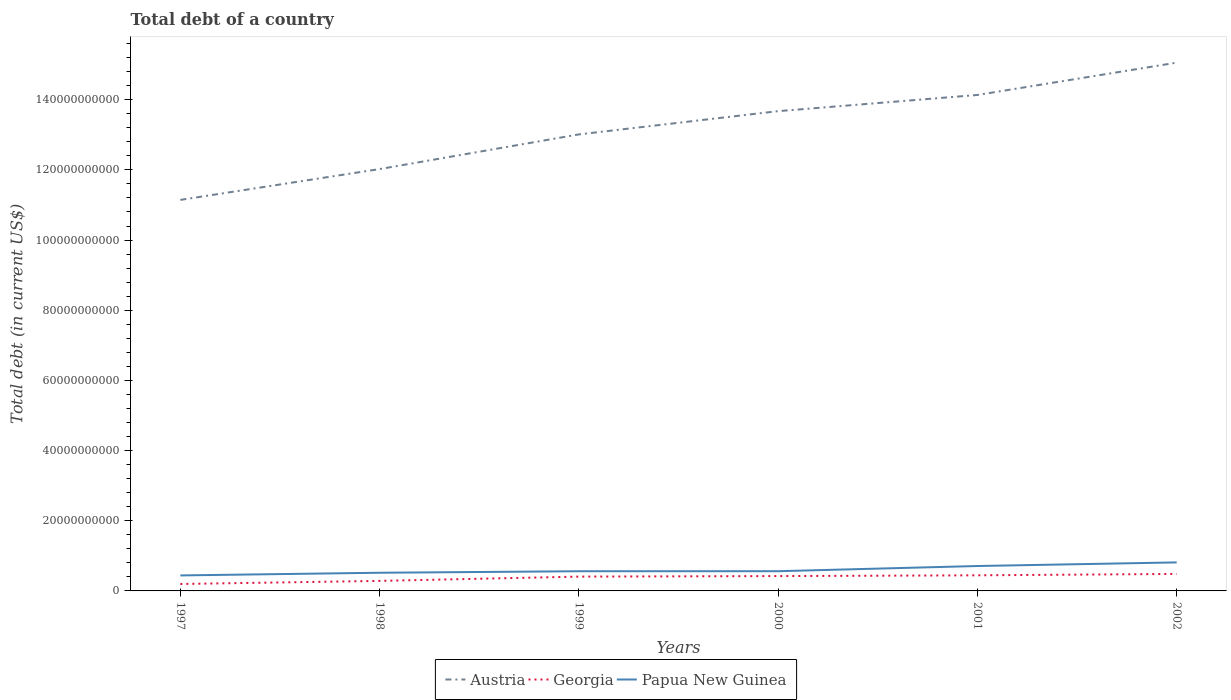Is the number of lines equal to the number of legend labels?
Keep it short and to the point. Yes. Across all years, what is the maximum debt in Papua New Guinea?
Offer a terse response. 4.42e+09. In which year was the debt in Papua New Guinea maximum?
Offer a very short reply. 1997. What is the total debt in Papua New Guinea in the graph?
Keep it short and to the point. -2.68e+09. What is the difference between the highest and the second highest debt in Papua New Guinea?
Your response must be concise. 3.71e+09. Does the graph contain any zero values?
Provide a short and direct response. No. Does the graph contain grids?
Make the answer very short. No. How many legend labels are there?
Your answer should be compact. 3. What is the title of the graph?
Give a very brief answer. Total debt of a country. Does "Libya" appear as one of the legend labels in the graph?
Offer a terse response. No. What is the label or title of the Y-axis?
Your answer should be very brief. Total debt (in current US$). What is the Total debt (in current US$) of Austria in 1997?
Offer a terse response. 1.11e+11. What is the Total debt (in current US$) of Georgia in 1997?
Your answer should be compact. 1.98e+09. What is the Total debt (in current US$) of Papua New Guinea in 1997?
Your answer should be compact. 4.42e+09. What is the Total debt (in current US$) of Austria in 1998?
Ensure brevity in your answer.  1.20e+11. What is the Total debt (in current US$) in Georgia in 1998?
Make the answer very short. 2.86e+09. What is the Total debt (in current US$) of Papua New Guinea in 1998?
Provide a succinct answer. 5.18e+09. What is the Total debt (in current US$) of Austria in 1999?
Offer a very short reply. 1.30e+11. What is the Total debt (in current US$) of Georgia in 1999?
Keep it short and to the point. 4.08e+09. What is the Total debt (in current US$) of Papua New Guinea in 1999?
Provide a short and direct response. 5.61e+09. What is the Total debt (in current US$) of Austria in 2000?
Keep it short and to the point. 1.37e+11. What is the Total debt (in current US$) in Georgia in 2000?
Offer a terse response. 4.23e+09. What is the Total debt (in current US$) of Papua New Guinea in 2000?
Make the answer very short. 5.62e+09. What is the Total debt (in current US$) in Austria in 2001?
Offer a very short reply. 1.41e+11. What is the Total debt (in current US$) in Georgia in 2001?
Keep it short and to the point. 4.45e+09. What is the Total debt (in current US$) in Papua New Guinea in 2001?
Provide a short and direct response. 7.10e+09. What is the Total debt (in current US$) in Austria in 2002?
Offer a very short reply. 1.51e+11. What is the Total debt (in current US$) in Georgia in 2002?
Your response must be concise. 4.84e+09. What is the Total debt (in current US$) in Papua New Guinea in 2002?
Your response must be concise. 8.13e+09. Across all years, what is the maximum Total debt (in current US$) in Austria?
Your answer should be very brief. 1.51e+11. Across all years, what is the maximum Total debt (in current US$) in Georgia?
Provide a short and direct response. 4.84e+09. Across all years, what is the maximum Total debt (in current US$) of Papua New Guinea?
Offer a very short reply. 8.13e+09. Across all years, what is the minimum Total debt (in current US$) of Austria?
Your response must be concise. 1.11e+11. Across all years, what is the minimum Total debt (in current US$) in Georgia?
Your answer should be very brief. 1.98e+09. Across all years, what is the minimum Total debt (in current US$) of Papua New Guinea?
Make the answer very short. 4.42e+09. What is the total Total debt (in current US$) of Austria in the graph?
Give a very brief answer. 7.90e+11. What is the total Total debt (in current US$) of Georgia in the graph?
Offer a terse response. 2.24e+1. What is the total Total debt (in current US$) of Papua New Guinea in the graph?
Provide a succinct answer. 3.61e+1. What is the difference between the Total debt (in current US$) in Austria in 1997 and that in 1998?
Your answer should be very brief. -8.79e+09. What is the difference between the Total debt (in current US$) of Georgia in 1997 and that in 1998?
Keep it short and to the point. -8.81e+08. What is the difference between the Total debt (in current US$) of Papua New Guinea in 1997 and that in 1998?
Give a very brief answer. -7.60e+08. What is the difference between the Total debt (in current US$) of Austria in 1997 and that in 1999?
Ensure brevity in your answer.  -1.87e+1. What is the difference between the Total debt (in current US$) of Georgia in 1997 and that in 1999?
Provide a succinct answer. -2.10e+09. What is the difference between the Total debt (in current US$) in Papua New Guinea in 1997 and that in 1999?
Give a very brief answer. -1.19e+09. What is the difference between the Total debt (in current US$) of Austria in 1997 and that in 2000?
Provide a succinct answer. -2.53e+1. What is the difference between the Total debt (in current US$) in Georgia in 1997 and that in 2000?
Your answer should be very brief. -2.25e+09. What is the difference between the Total debt (in current US$) of Papua New Guinea in 1997 and that in 2000?
Provide a short and direct response. -1.20e+09. What is the difference between the Total debt (in current US$) in Austria in 1997 and that in 2001?
Offer a very short reply. -2.99e+1. What is the difference between the Total debt (in current US$) in Georgia in 1997 and that in 2001?
Your response must be concise. -2.47e+09. What is the difference between the Total debt (in current US$) in Papua New Guinea in 1997 and that in 2001?
Your answer should be very brief. -2.68e+09. What is the difference between the Total debt (in current US$) of Austria in 1997 and that in 2002?
Your response must be concise. -3.91e+1. What is the difference between the Total debt (in current US$) in Georgia in 1997 and that in 2002?
Your answer should be very brief. -2.87e+09. What is the difference between the Total debt (in current US$) of Papua New Guinea in 1997 and that in 2002?
Your response must be concise. -3.71e+09. What is the difference between the Total debt (in current US$) in Austria in 1998 and that in 1999?
Your answer should be compact. -9.88e+09. What is the difference between the Total debt (in current US$) in Georgia in 1998 and that in 1999?
Ensure brevity in your answer.  -1.22e+09. What is the difference between the Total debt (in current US$) in Papua New Guinea in 1998 and that in 1999?
Provide a short and direct response. -4.32e+08. What is the difference between the Total debt (in current US$) in Austria in 1998 and that in 2000?
Ensure brevity in your answer.  -1.65e+1. What is the difference between the Total debt (in current US$) of Georgia in 1998 and that in 2000?
Ensure brevity in your answer.  -1.37e+09. What is the difference between the Total debt (in current US$) of Papua New Guinea in 1998 and that in 2000?
Provide a short and direct response. -4.44e+08. What is the difference between the Total debt (in current US$) in Austria in 1998 and that in 2001?
Offer a terse response. -2.11e+1. What is the difference between the Total debt (in current US$) in Georgia in 1998 and that in 2001?
Provide a succinct answer. -1.59e+09. What is the difference between the Total debt (in current US$) of Papua New Guinea in 1998 and that in 2001?
Provide a short and direct response. -1.92e+09. What is the difference between the Total debt (in current US$) in Austria in 1998 and that in 2002?
Provide a short and direct response. -3.03e+1. What is the difference between the Total debt (in current US$) in Georgia in 1998 and that in 2002?
Your answer should be very brief. -1.99e+09. What is the difference between the Total debt (in current US$) of Papua New Guinea in 1998 and that in 2002?
Your answer should be compact. -2.95e+09. What is the difference between the Total debt (in current US$) in Austria in 1999 and that in 2000?
Keep it short and to the point. -6.63e+09. What is the difference between the Total debt (in current US$) in Georgia in 1999 and that in 2000?
Your response must be concise. -1.48e+08. What is the difference between the Total debt (in current US$) in Papua New Guinea in 1999 and that in 2000?
Your response must be concise. -1.24e+07. What is the difference between the Total debt (in current US$) in Austria in 1999 and that in 2001?
Offer a very short reply. -1.12e+1. What is the difference between the Total debt (in current US$) in Georgia in 1999 and that in 2001?
Provide a succinct answer. -3.72e+08. What is the difference between the Total debt (in current US$) of Papua New Guinea in 1999 and that in 2001?
Give a very brief answer. -1.49e+09. What is the difference between the Total debt (in current US$) in Austria in 1999 and that in 2002?
Offer a very short reply. -2.05e+1. What is the difference between the Total debt (in current US$) in Georgia in 1999 and that in 2002?
Provide a short and direct response. -7.65e+08. What is the difference between the Total debt (in current US$) of Papua New Guinea in 1999 and that in 2002?
Your response must be concise. -2.52e+09. What is the difference between the Total debt (in current US$) in Austria in 2000 and that in 2001?
Offer a terse response. -4.61e+09. What is the difference between the Total debt (in current US$) in Georgia in 2000 and that in 2001?
Make the answer very short. -2.23e+08. What is the difference between the Total debt (in current US$) in Papua New Guinea in 2000 and that in 2001?
Give a very brief answer. -1.48e+09. What is the difference between the Total debt (in current US$) in Austria in 2000 and that in 2002?
Your answer should be very brief. -1.38e+1. What is the difference between the Total debt (in current US$) of Georgia in 2000 and that in 2002?
Your response must be concise. -6.17e+08. What is the difference between the Total debt (in current US$) of Papua New Guinea in 2000 and that in 2002?
Provide a short and direct response. -2.51e+09. What is the difference between the Total debt (in current US$) of Austria in 2001 and that in 2002?
Provide a succinct answer. -9.21e+09. What is the difference between the Total debt (in current US$) of Georgia in 2001 and that in 2002?
Your answer should be compact. -3.94e+08. What is the difference between the Total debt (in current US$) of Papua New Guinea in 2001 and that in 2002?
Make the answer very short. -1.03e+09. What is the difference between the Total debt (in current US$) in Austria in 1997 and the Total debt (in current US$) in Georgia in 1998?
Offer a very short reply. 1.09e+11. What is the difference between the Total debt (in current US$) in Austria in 1997 and the Total debt (in current US$) in Papua New Guinea in 1998?
Make the answer very short. 1.06e+11. What is the difference between the Total debt (in current US$) in Georgia in 1997 and the Total debt (in current US$) in Papua New Guinea in 1998?
Ensure brevity in your answer.  -3.20e+09. What is the difference between the Total debt (in current US$) of Austria in 1997 and the Total debt (in current US$) of Georgia in 1999?
Ensure brevity in your answer.  1.07e+11. What is the difference between the Total debt (in current US$) in Austria in 1997 and the Total debt (in current US$) in Papua New Guinea in 1999?
Ensure brevity in your answer.  1.06e+11. What is the difference between the Total debt (in current US$) in Georgia in 1997 and the Total debt (in current US$) in Papua New Guinea in 1999?
Provide a short and direct response. -3.63e+09. What is the difference between the Total debt (in current US$) of Austria in 1997 and the Total debt (in current US$) of Georgia in 2000?
Keep it short and to the point. 1.07e+11. What is the difference between the Total debt (in current US$) in Austria in 1997 and the Total debt (in current US$) in Papua New Guinea in 2000?
Your response must be concise. 1.06e+11. What is the difference between the Total debt (in current US$) in Georgia in 1997 and the Total debt (in current US$) in Papua New Guinea in 2000?
Offer a very short reply. -3.64e+09. What is the difference between the Total debt (in current US$) of Austria in 1997 and the Total debt (in current US$) of Georgia in 2001?
Offer a very short reply. 1.07e+11. What is the difference between the Total debt (in current US$) in Austria in 1997 and the Total debt (in current US$) in Papua New Guinea in 2001?
Give a very brief answer. 1.04e+11. What is the difference between the Total debt (in current US$) of Georgia in 1997 and the Total debt (in current US$) of Papua New Guinea in 2001?
Offer a very short reply. -5.12e+09. What is the difference between the Total debt (in current US$) in Austria in 1997 and the Total debt (in current US$) in Georgia in 2002?
Provide a succinct answer. 1.07e+11. What is the difference between the Total debt (in current US$) in Austria in 1997 and the Total debt (in current US$) in Papua New Guinea in 2002?
Give a very brief answer. 1.03e+11. What is the difference between the Total debt (in current US$) of Georgia in 1997 and the Total debt (in current US$) of Papua New Guinea in 2002?
Your answer should be very brief. -6.15e+09. What is the difference between the Total debt (in current US$) of Austria in 1998 and the Total debt (in current US$) of Georgia in 1999?
Ensure brevity in your answer.  1.16e+11. What is the difference between the Total debt (in current US$) in Austria in 1998 and the Total debt (in current US$) in Papua New Guinea in 1999?
Provide a short and direct response. 1.15e+11. What is the difference between the Total debt (in current US$) of Georgia in 1998 and the Total debt (in current US$) of Papua New Guinea in 1999?
Give a very brief answer. -2.75e+09. What is the difference between the Total debt (in current US$) of Austria in 1998 and the Total debt (in current US$) of Georgia in 2000?
Your answer should be compact. 1.16e+11. What is the difference between the Total debt (in current US$) in Austria in 1998 and the Total debt (in current US$) in Papua New Guinea in 2000?
Provide a succinct answer. 1.15e+11. What is the difference between the Total debt (in current US$) in Georgia in 1998 and the Total debt (in current US$) in Papua New Guinea in 2000?
Provide a short and direct response. -2.76e+09. What is the difference between the Total debt (in current US$) of Austria in 1998 and the Total debt (in current US$) of Georgia in 2001?
Make the answer very short. 1.16e+11. What is the difference between the Total debt (in current US$) of Austria in 1998 and the Total debt (in current US$) of Papua New Guinea in 2001?
Offer a very short reply. 1.13e+11. What is the difference between the Total debt (in current US$) of Georgia in 1998 and the Total debt (in current US$) of Papua New Guinea in 2001?
Make the answer very short. -4.24e+09. What is the difference between the Total debt (in current US$) in Austria in 1998 and the Total debt (in current US$) in Georgia in 2002?
Provide a succinct answer. 1.15e+11. What is the difference between the Total debt (in current US$) in Austria in 1998 and the Total debt (in current US$) in Papua New Guinea in 2002?
Provide a short and direct response. 1.12e+11. What is the difference between the Total debt (in current US$) of Georgia in 1998 and the Total debt (in current US$) of Papua New Guinea in 2002?
Provide a succinct answer. -5.27e+09. What is the difference between the Total debt (in current US$) in Austria in 1999 and the Total debt (in current US$) in Georgia in 2000?
Provide a succinct answer. 1.26e+11. What is the difference between the Total debt (in current US$) of Austria in 1999 and the Total debt (in current US$) of Papua New Guinea in 2000?
Keep it short and to the point. 1.24e+11. What is the difference between the Total debt (in current US$) in Georgia in 1999 and the Total debt (in current US$) in Papua New Guinea in 2000?
Your response must be concise. -1.54e+09. What is the difference between the Total debt (in current US$) in Austria in 1999 and the Total debt (in current US$) in Georgia in 2001?
Offer a terse response. 1.26e+11. What is the difference between the Total debt (in current US$) of Austria in 1999 and the Total debt (in current US$) of Papua New Guinea in 2001?
Your answer should be compact. 1.23e+11. What is the difference between the Total debt (in current US$) of Georgia in 1999 and the Total debt (in current US$) of Papua New Guinea in 2001?
Provide a succinct answer. -3.02e+09. What is the difference between the Total debt (in current US$) in Austria in 1999 and the Total debt (in current US$) in Georgia in 2002?
Your answer should be very brief. 1.25e+11. What is the difference between the Total debt (in current US$) in Austria in 1999 and the Total debt (in current US$) in Papua New Guinea in 2002?
Your response must be concise. 1.22e+11. What is the difference between the Total debt (in current US$) in Georgia in 1999 and the Total debt (in current US$) in Papua New Guinea in 2002?
Your answer should be compact. -4.05e+09. What is the difference between the Total debt (in current US$) in Austria in 2000 and the Total debt (in current US$) in Georgia in 2001?
Keep it short and to the point. 1.32e+11. What is the difference between the Total debt (in current US$) of Austria in 2000 and the Total debt (in current US$) of Papua New Guinea in 2001?
Your response must be concise. 1.30e+11. What is the difference between the Total debt (in current US$) of Georgia in 2000 and the Total debt (in current US$) of Papua New Guinea in 2001?
Provide a succinct answer. -2.87e+09. What is the difference between the Total debt (in current US$) of Austria in 2000 and the Total debt (in current US$) of Georgia in 2002?
Your response must be concise. 1.32e+11. What is the difference between the Total debt (in current US$) of Austria in 2000 and the Total debt (in current US$) of Papua New Guinea in 2002?
Your response must be concise. 1.29e+11. What is the difference between the Total debt (in current US$) of Georgia in 2000 and the Total debt (in current US$) of Papua New Guinea in 2002?
Make the answer very short. -3.90e+09. What is the difference between the Total debt (in current US$) of Austria in 2001 and the Total debt (in current US$) of Georgia in 2002?
Make the answer very short. 1.37e+11. What is the difference between the Total debt (in current US$) of Austria in 2001 and the Total debt (in current US$) of Papua New Guinea in 2002?
Your response must be concise. 1.33e+11. What is the difference between the Total debt (in current US$) of Georgia in 2001 and the Total debt (in current US$) of Papua New Guinea in 2002?
Offer a very short reply. -3.68e+09. What is the average Total debt (in current US$) in Austria per year?
Your response must be concise. 1.32e+11. What is the average Total debt (in current US$) in Georgia per year?
Your answer should be very brief. 3.74e+09. What is the average Total debt (in current US$) of Papua New Guinea per year?
Give a very brief answer. 6.01e+09. In the year 1997, what is the difference between the Total debt (in current US$) in Austria and Total debt (in current US$) in Georgia?
Your answer should be very brief. 1.09e+11. In the year 1997, what is the difference between the Total debt (in current US$) in Austria and Total debt (in current US$) in Papua New Guinea?
Ensure brevity in your answer.  1.07e+11. In the year 1997, what is the difference between the Total debt (in current US$) in Georgia and Total debt (in current US$) in Papua New Guinea?
Make the answer very short. -2.44e+09. In the year 1998, what is the difference between the Total debt (in current US$) in Austria and Total debt (in current US$) in Georgia?
Keep it short and to the point. 1.17e+11. In the year 1998, what is the difference between the Total debt (in current US$) of Austria and Total debt (in current US$) of Papua New Guinea?
Offer a very short reply. 1.15e+11. In the year 1998, what is the difference between the Total debt (in current US$) of Georgia and Total debt (in current US$) of Papua New Guinea?
Your answer should be very brief. -2.32e+09. In the year 1999, what is the difference between the Total debt (in current US$) in Austria and Total debt (in current US$) in Georgia?
Your answer should be very brief. 1.26e+11. In the year 1999, what is the difference between the Total debt (in current US$) in Austria and Total debt (in current US$) in Papua New Guinea?
Give a very brief answer. 1.24e+11. In the year 1999, what is the difference between the Total debt (in current US$) of Georgia and Total debt (in current US$) of Papua New Guinea?
Give a very brief answer. -1.53e+09. In the year 2000, what is the difference between the Total debt (in current US$) of Austria and Total debt (in current US$) of Georgia?
Make the answer very short. 1.33e+11. In the year 2000, what is the difference between the Total debt (in current US$) of Austria and Total debt (in current US$) of Papua New Guinea?
Your answer should be very brief. 1.31e+11. In the year 2000, what is the difference between the Total debt (in current US$) in Georgia and Total debt (in current US$) in Papua New Guinea?
Your answer should be compact. -1.40e+09. In the year 2001, what is the difference between the Total debt (in current US$) in Austria and Total debt (in current US$) in Georgia?
Your response must be concise. 1.37e+11. In the year 2001, what is the difference between the Total debt (in current US$) in Austria and Total debt (in current US$) in Papua New Guinea?
Offer a very short reply. 1.34e+11. In the year 2001, what is the difference between the Total debt (in current US$) of Georgia and Total debt (in current US$) of Papua New Guinea?
Offer a terse response. -2.65e+09. In the year 2002, what is the difference between the Total debt (in current US$) in Austria and Total debt (in current US$) in Georgia?
Offer a very short reply. 1.46e+11. In the year 2002, what is the difference between the Total debt (in current US$) in Austria and Total debt (in current US$) in Papua New Guinea?
Your answer should be very brief. 1.42e+11. In the year 2002, what is the difference between the Total debt (in current US$) of Georgia and Total debt (in current US$) of Papua New Guinea?
Give a very brief answer. -3.28e+09. What is the ratio of the Total debt (in current US$) in Austria in 1997 to that in 1998?
Provide a short and direct response. 0.93. What is the ratio of the Total debt (in current US$) in Georgia in 1997 to that in 1998?
Give a very brief answer. 0.69. What is the ratio of the Total debt (in current US$) in Papua New Guinea in 1997 to that in 1998?
Keep it short and to the point. 0.85. What is the ratio of the Total debt (in current US$) of Austria in 1997 to that in 1999?
Provide a succinct answer. 0.86. What is the ratio of the Total debt (in current US$) of Georgia in 1997 to that in 1999?
Provide a short and direct response. 0.48. What is the ratio of the Total debt (in current US$) of Papua New Guinea in 1997 to that in 1999?
Your response must be concise. 0.79. What is the ratio of the Total debt (in current US$) of Austria in 1997 to that in 2000?
Your response must be concise. 0.81. What is the ratio of the Total debt (in current US$) of Georgia in 1997 to that in 2000?
Offer a very short reply. 0.47. What is the ratio of the Total debt (in current US$) in Papua New Guinea in 1997 to that in 2000?
Offer a terse response. 0.79. What is the ratio of the Total debt (in current US$) in Austria in 1997 to that in 2001?
Your response must be concise. 0.79. What is the ratio of the Total debt (in current US$) in Georgia in 1997 to that in 2001?
Offer a terse response. 0.44. What is the ratio of the Total debt (in current US$) in Papua New Guinea in 1997 to that in 2001?
Offer a very short reply. 0.62. What is the ratio of the Total debt (in current US$) of Austria in 1997 to that in 2002?
Provide a short and direct response. 0.74. What is the ratio of the Total debt (in current US$) of Georgia in 1997 to that in 2002?
Ensure brevity in your answer.  0.41. What is the ratio of the Total debt (in current US$) in Papua New Guinea in 1997 to that in 2002?
Provide a short and direct response. 0.54. What is the ratio of the Total debt (in current US$) of Austria in 1998 to that in 1999?
Provide a succinct answer. 0.92. What is the ratio of the Total debt (in current US$) of Georgia in 1998 to that in 1999?
Provide a succinct answer. 0.7. What is the ratio of the Total debt (in current US$) of Austria in 1998 to that in 2000?
Make the answer very short. 0.88. What is the ratio of the Total debt (in current US$) in Georgia in 1998 to that in 2000?
Your answer should be very brief. 0.68. What is the ratio of the Total debt (in current US$) of Papua New Guinea in 1998 to that in 2000?
Keep it short and to the point. 0.92. What is the ratio of the Total debt (in current US$) in Austria in 1998 to that in 2001?
Your response must be concise. 0.85. What is the ratio of the Total debt (in current US$) in Georgia in 1998 to that in 2001?
Make the answer very short. 0.64. What is the ratio of the Total debt (in current US$) in Papua New Guinea in 1998 to that in 2001?
Your answer should be very brief. 0.73. What is the ratio of the Total debt (in current US$) of Austria in 1998 to that in 2002?
Your response must be concise. 0.8. What is the ratio of the Total debt (in current US$) in Georgia in 1998 to that in 2002?
Make the answer very short. 0.59. What is the ratio of the Total debt (in current US$) of Papua New Guinea in 1998 to that in 2002?
Keep it short and to the point. 0.64. What is the ratio of the Total debt (in current US$) in Austria in 1999 to that in 2000?
Provide a short and direct response. 0.95. What is the ratio of the Total debt (in current US$) of Georgia in 1999 to that in 2000?
Offer a very short reply. 0.96. What is the ratio of the Total debt (in current US$) in Austria in 1999 to that in 2001?
Provide a succinct answer. 0.92. What is the ratio of the Total debt (in current US$) of Georgia in 1999 to that in 2001?
Keep it short and to the point. 0.92. What is the ratio of the Total debt (in current US$) in Papua New Guinea in 1999 to that in 2001?
Provide a short and direct response. 0.79. What is the ratio of the Total debt (in current US$) of Austria in 1999 to that in 2002?
Provide a short and direct response. 0.86. What is the ratio of the Total debt (in current US$) in Georgia in 1999 to that in 2002?
Provide a succinct answer. 0.84. What is the ratio of the Total debt (in current US$) of Papua New Guinea in 1999 to that in 2002?
Offer a very short reply. 0.69. What is the ratio of the Total debt (in current US$) in Austria in 2000 to that in 2001?
Provide a succinct answer. 0.97. What is the ratio of the Total debt (in current US$) of Georgia in 2000 to that in 2001?
Ensure brevity in your answer.  0.95. What is the ratio of the Total debt (in current US$) of Papua New Guinea in 2000 to that in 2001?
Offer a very short reply. 0.79. What is the ratio of the Total debt (in current US$) of Austria in 2000 to that in 2002?
Provide a succinct answer. 0.91. What is the ratio of the Total debt (in current US$) of Georgia in 2000 to that in 2002?
Keep it short and to the point. 0.87. What is the ratio of the Total debt (in current US$) in Papua New Guinea in 2000 to that in 2002?
Make the answer very short. 0.69. What is the ratio of the Total debt (in current US$) of Austria in 2001 to that in 2002?
Give a very brief answer. 0.94. What is the ratio of the Total debt (in current US$) of Georgia in 2001 to that in 2002?
Your answer should be compact. 0.92. What is the ratio of the Total debt (in current US$) in Papua New Guinea in 2001 to that in 2002?
Provide a short and direct response. 0.87. What is the difference between the highest and the second highest Total debt (in current US$) of Austria?
Your answer should be very brief. 9.21e+09. What is the difference between the highest and the second highest Total debt (in current US$) of Georgia?
Provide a short and direct response. 3.94e+08. What is the difference between the highest and the second highest Total debt (in current US$) in Papua New Guinea?
Provide a short and direct response. 1.03e+09. What is the difference between the highest and the lowest Total debt (in current US$) of Austria?
Give a very brief answer. 3.91e+1. What is the difference between the highest and the lowest Total debt (in current US$) in Georgia?
Give a very brief answer. 2.87e+09. What is the difference between the highest and the lowest Total debt (in current US$) of Papua New Guinea?
Give a very brief answer. 3.71e+09. 